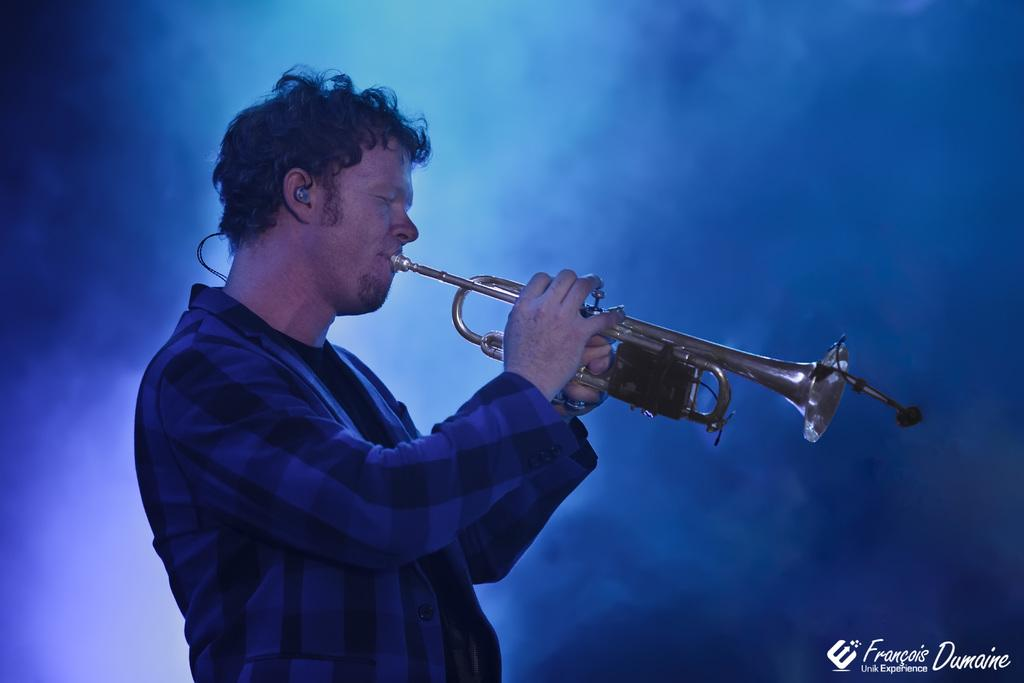What is the main subject of the image? The main subject of the image is a man. What is the man doing in the image? The man is standing and playing a musical instrument. Is there any additional information about the image? Yes, there is a watermark in the bottom right corner of the image. What type of skate is the man using to play the musical instrument in the image? There is no skate present in the image; the man is playing a musical instrument while standing. Can you tell me the relationship between the man and the person taking the photo in the image? The provided facts do not mention any other person or relationship between the man and the person taking the photo. 